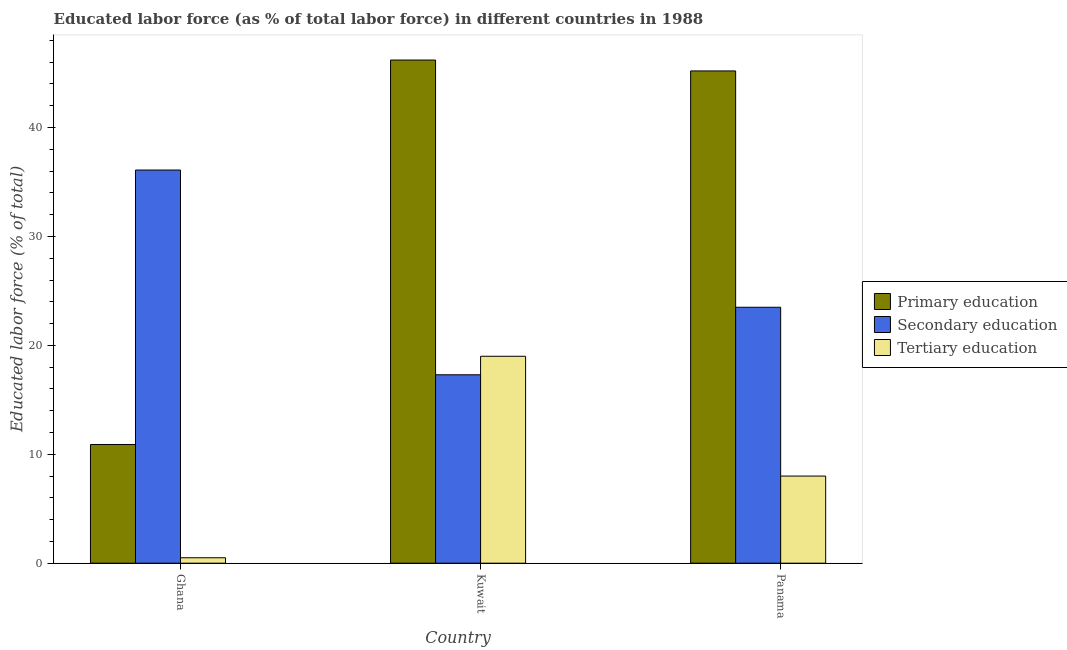Are the number of bars on each tick of the X-axis equal?
Make the answer very short. Yes. How many bars are there on the 3rd tick from the left?
Offer a very short reply. 3. How many bars are there on the 2nd tick from the right?
Offer a very short reply. 3. What is the label of the 2nd group of bars from the left?
Provide a short and direct response. Kuwait. In how many cases, is the number of bars for a given country not equal to the number of legend labels?
Make the answer very short. 0. What is the percentage of labor force who received primary education in Ghana?
Offer a very short reply. 10.9. Across all countries, what is the maximum percentage of labor force who received primary education?
Your response must be concise. 46.2. Across all countries, what is the minimum percentage of labor force who received tertiary education?
Provide a short and direct response. 0.5. In which country was the percentage of labor force who received tertiary education maximum?
Your answer should be very brief. Kuwait. What is the total percentage of labor force who received secondary education in the graph?
Your answer should be compact. 76.9. What is the difference between the percentage of labor force who received secondary education in Kuwait and that in Panama?
Your response must be concise. -6.2. What is the difference between the percentage of labor force who received primary education in Kuwait and the percentage of labor force who received secondary education in Panama?
Provide a succinct answer. 22.7. What is the average percentage of labor force who received secondary education per country?
Your answer should be very brief. 25.63. What is the difference between the percentage of labor force who received tertiary education and percentage of labor force who received secondary education in Panama?
Your response must be concise. -15.5. What is the ratio of the percentage of labor force who received tertiary education in Ghana to that in Panama?
Offer a very short reply. 0.06. Is the percentage of labor force who received tertiary education in Kuwait less than that in Panama?
Keep it short and to the point. No. What is the difference between the highest and the second highest percentage of labor force who received secondary education?
Provide a short and direct response. 12.6. What is the difference between the highest and the lowest percentage of labor force who received tertiary education?
Provide a short and direct response. 18.5. In how many countries, is the percentage of labor force who received primary education greater than the average percentage of labor force who received primary education taken over all countries?
Offer a terse response. 2. What does the 3rd bar from the left in Panama represents?
Offer a very short reply. Tertiary education. What does the 2nd bar from the right in Panama represents?
Your response must be concise. Secondary education. How many bars are there?
Give a very brief answer. 9. How many countries are there in the graph?
Provide a short and direct response. 3. Are the values on the major ticks of Y-axis written in scientific E-notation?
Your response must be concise. No. Does the graph contain any zero values?
Provide a short and direct response. No. Does the graph contain grids?
Offer a very short reply. No. How many legend labels are there?
Provide a short and direct response. 3. How are the legend labels stacked?
Ensure brevity in your answer.  Vertical. What is the title of the graph?
Give a very brief answer. Educated labor force (as % of total labor force) in different countries in 1988. Does "Social insurance" appear as one of the legend labels in the graph?
Keep it short and to the point. No. What is the label or title of the X-axis?
Offer a terse response. Country. What is the label or title of the Y-axis?
Provide a succinct answer. Educated labor force (% of total). What is the Educated labor force (% of total) in Primary education in Ghana?
Your answer should be very brief. 10.9. What is the Educated labor force (% of total) in Secondary education in Ghana?
Your response must be concise. 36.1. What is the Educated labor force (% of total) of Tertiary education in Ghana?
Offer a very short reply. 0.5. What is the Educated labor force (% of total) of Primary education in Kuwait?
Make the answer very short. 46.2. What is the Educated labor force (% of total) in Secondary education in Kuwait?
Your answer should be compact. 17.3. What is the Educated labor force (% of total) of Primary education in Panama?
Your answer should be very brief. 45.2. What is the Educated labor force (% of total) in Secondary education in Panama?
Provide a short and direct response. 23.5. What is the Educated labor force (% of total) of Tertiary education in Panama?
Provide a succinct answer. 8. Across all countries, what is the maximum Educated labor force (% of total) in Primary education?
Give a very brief answer. 46.2. Across all countries, what is the maximum Educated labor force (% of total) in Secondary education?
Offer a terse response. 36.1. Across all countries, what is the minimum Educated labor force (% of total) of Primary education?
Your response must be concise. 10.9. Across all countries, what is the minimum Educated labor force (% of total) in Secondary education?
Provide a short and direct response. 17.3. Across all countries, what is the minimum Educated labor force (% of total) in Tertiary education?
Your answer should be very brief. 0.5. What is the total Educated labor force (% of total) in Primary education in the graph?
Your answer should be very brief. 102.3. What is the total Educated labor force (% of total) of Secondary education in the graph?
Provide a short and direct response. 76.9. What is the difference between the Educated labor force (% of total) of Primary education in Ghana and that in Kuwait?
Your answer should be compact. -35.3. What is the difference between the Educated labor force (% of total) of Tertiary education in Ghana and that in Kuwait?
Ensure brevity in your answer.  -18.5. What is the difference between the Educated labor force (% of total) in Primary education in Ghana and that in Panama?
Your answer should be very brief. -34.3. What is the difference between the Educated labor force (% of total) in Tertiary education in Ghana and that in Panama?
Provide a succinct answer. -7.5. What is the difference between the Educated labor force (% of total) of Primary education in Kuwait and that in Panama?
Your response must be concise. 1. What is the difference between the Educated labor force (% of total) of Primary education in Ghana and the Educated labor force (% of total) of Tertiary education in Kuwait?
Your answer should be compact. -8.1. What is the difference between the Educated labor force (% of total) of Primary education in Ghana and the Educated labor force (% of total) of Secondary education in Panama?
Provide a short and direct response. -12.6. What is the difference between the Educated labor force (% of total) in Secondary education in Ghana and the Educated labor force (% of total) in Tertiary education in Panama?
Give a very brief answer. 28.1. What is the difference between the Educated labor force (% of total) of Primary education in Kuwait and the Educated labor force (% of total) of Secondary education in Panama?
Provide a short and direct response. 22.7. What is the difference between the Educated labor force (% of total) in Primary education in Kuwait and the Educated labor force (% of total) in Tertiary education in Panama?
Provide a short and direct response. 38.2. What is the average Educated labor force (% of total) of Primary education per country?
Your answer should be compact. 34.1. What is the average Educated labor force (% of total) of Secondary education per country?
Make the answer very short. 25.63. What is the average Educated labor force (% of total) of Tertiary education per country?
Provide a short and direct response. 9.17. What is the difference between the Educated labor force (% of total) of Primary education and Educated labor force (% of total) of Secondary education in Ghana?
Your answer should be compact. -25.2. What is the difference between the Educated labor force (% of total) of Secondary education and Educated labor force (% of total) of Tertiary education in Ghana?
Keep it short and to the point. 35.6. What is the difference between the Educated labor force (% of total) of Primary education and Educated labor force (% of total) of Secondary education in Kuwait?
Give a very brief answer. 28.9. What is the difference between the Educated labor force (% of total) of Primary education and Educated labor force (% of total) of Tertiary education in Kuwait?
Ensure brevity in your answer.  27.2. What is the difference between the Educated labor force (% of total) of Secondary education and Educated labor force (% of total) of Tertiary education in Kuwait?
Your answer should be compact. -1.7. What is the difference between the Educated labor force (% of total) in Primary education and Educated labor force (% of total) in Secondary education in Panama?
Ensure brevity in your answer.  21.7. What is the difference between the Educated labor force (% of total) of Primary education and Educated labor force (% of total) of Tertiary education in Panama?
Your answer should be compact. 37.2. What is the difference between the Educated labor force (% of total) in Secondary education and Educated labor force (% of total) in Tertiary education in Panama?
Offer a very short reply. 15.5. What is the ratio of the Educated labor force (% of total) of Primary education in Ghana to that in Kuwait?
Make the answer very short. 0.24. What is the ratio of the Educated labor force (% of total) of Secondary education in Ghana to that in Kuwait?
Your response must be concise. 2.09. What is the ratio of the Educated labor force (% of total) in Tertiary education in Ghana to that in Kuwait?
Your answer should be compact. 0.03. What is the ratio of the Educated labor force (% of total) in Primary education in Ghana to that in Panama?
Your answer should be compact. 0.24. What is the ratio of the Educated labor force (% of total) in Secondary education in Ghana to that in Panama?
Offer a terse response. 1.54. What is the ratio of the Educated labor force (% of total) in Tertiary education in Ghana to that in Panama?
Provide a short and direct response. 0.06. What is the ratio of the Educated labor force (% of total) of Primary education in Kuwait to that in Panama?
Offer a terse response. 1.02. What is the ratio of the Educated labor force (% of total) in Secondary education in Kuwait to that in Panama?
Your answer should be compact. 0.74. What is the ratio of the Educated labor force (% of total) of Tertiary education in Kuwait to that in Panama?
Your answer should be compact. 2.38. What is the difference between the highest and the second highest Educated labor force (% of total) in Secondary education?
Offer a very short reply. 12.6. What is the difference between the highest and the lowest Educated labor force (% of total) in Primary education?
Ensure brevity in your answer.  35.3. What is the difference between the highest and the lowest Educated labor force (% of total) in Secondary education?
Provide a short and direct response. 18.8. 